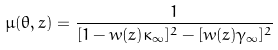<formula> <loc_0><loc_0><loc_500><loc_500>\mu ( \theta , z ) = \frac { 1 } { [ 1 - w ( z ) \kappa _ { \infty } ] ^ { 2 } - [ w ( z ) \gamma _ { \infty } ] ^ { 2 } }</formula> 